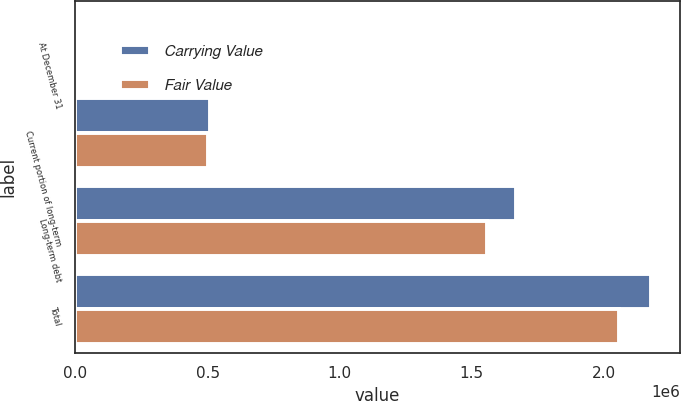Convert chart. <chart><loc_0><loc_0><loc_500><loc_500><stacked_bar_chart><ecel><fcel>At December 31<fcel>Current portion of long-term<fcel>Long-term debt<fcel>Total<nl><fcel>Carrying Value<fcel>2015<fcel>509580<fcel>1.66838e+06<fcel>2.17796e+06<nl><fcel>Fair Value<fcel>2015<fcel>499923<fcel>1.55709e+06<fcel>2.05701e+06<nl></chart> 